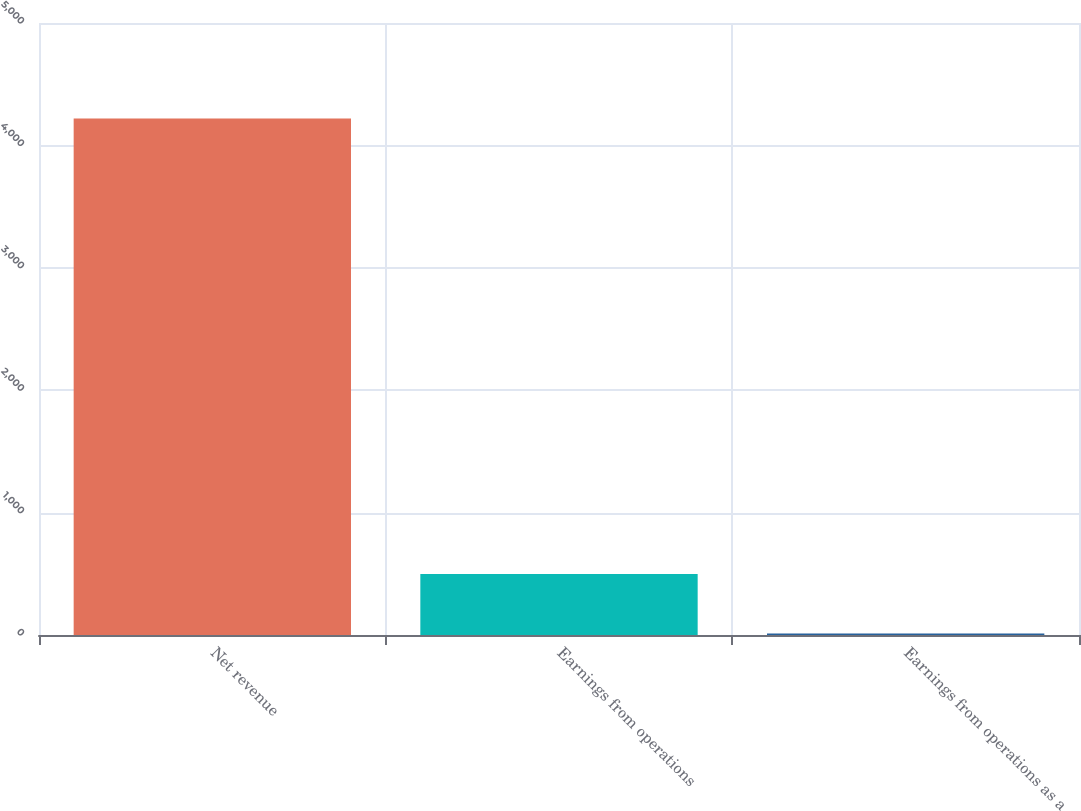Convert chart. <chart><loc_0><loc_0><loc_500><loc_500><bar_chart><fcel>Net revenue<fcel>Earnings from operations<fcel>Earnings from operations as a<nl><fcel>4220<fcel>499<fcel>11.8<nl></chart> 